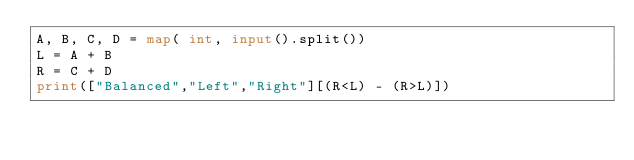Convert code to text. <code><loc_0><loc_0><loc_500><loc_500><_Python_>A, B, C, D = map( int, input().split())
L = A + B
R = C + D
print(["Balanced","Left","Right"][(R<L) - (R>L)])</code> 